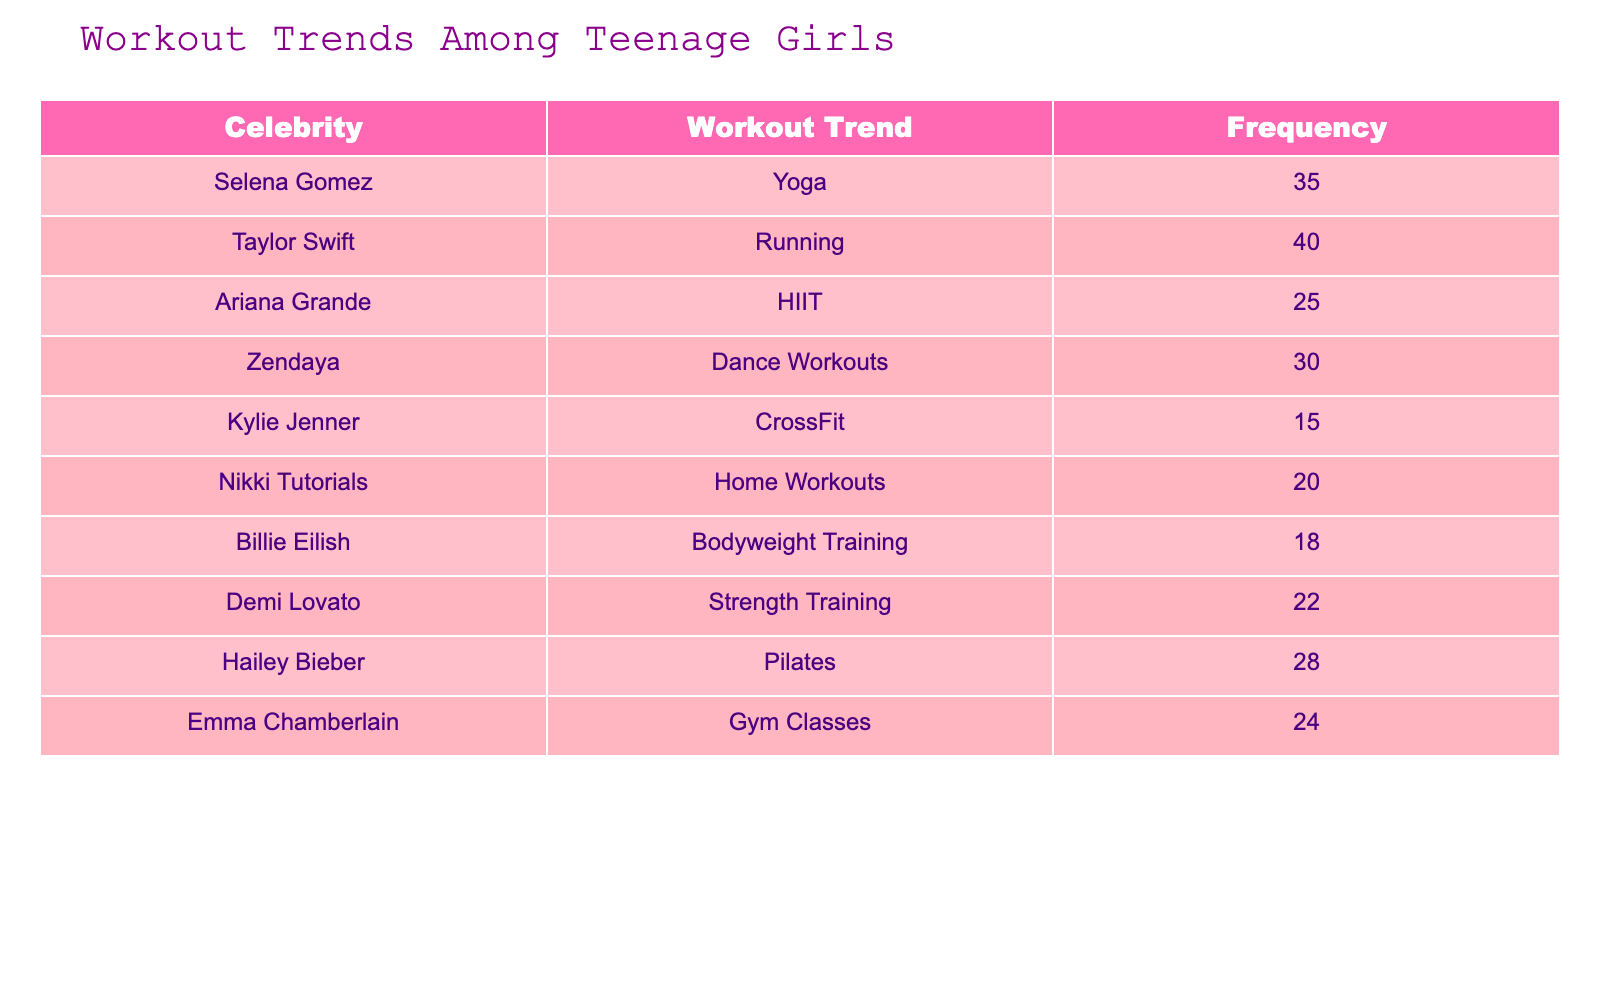What workout trend has the highest frequency among teenage girls? From the table, the highest frequency can be found by comparing the 'Frequency' values. The workout trend associated with Taylor Swift is Running with a frequency of 40, which is the highest when looking at all entries.
Answer: Running How many teenage girls follow Dance Workouts according to the data? By looking at the 'Frequency' column specifically for Dance Workouts, which is associated with Zendaya, we see the frequency listed as 30.
Answer: 30 What is the combined frequency of Home Workouts and Strength Training? We add the frequencies of Home Workouts (20) and Strength Training (22). So, 20 + 22 = 42. Thus, the combined frequency is 42.
Answer: 42 Is Pilates the most popular workout trend among teenage girls? The highest frequency entry is for Running at 40. Therefore, Pilates, which has a frequency of 28, is not the most popular.
Answer: No What is the average frequency of all workout trends listed in the table? To find the average, we first calculate the total frequency: 35 + 40 + 25 + 30 + 15 + 20 + 18 + 22 + 28 + 24 =  256. There are 10 entries, thus the average is 256 / 10 = 25.6.
Answer: 25.6 Which workout trend is associated with Billie Eilish and how many followers does it have? From the table, Billie Eilish is associated with Bodyweight Training, which has a frequency of 18.
Answer: Bodyweight Training, 18 What is the difference in frequency between the workout trends of Ariana Grande and Demi Lovato? Ariana Grande has 25 for HIIT and Demi Lovato has 22 for Strength Training. The difference is 25 - 22 = 3.
Answer: 3 Which two workout trends have the lowest frequency and what are their values? The lowest frequencies are from Kylie Jenner's CrossFit with 15 and Billie Eilish's Bodyweight Training with 18. Therefore, the lowest two are CrossFit: 15 and Bodyweight Training: 18.
Answer: CrossFit: 15, Bodyweight Training: 18 